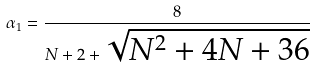Convert formula to latex. <formula><loc_0><loc_0><loc_500><loc_500>\alpha _ { 1 } = \frac { 8 } { N + 2 + \sqrt { N ^ { 2 } + 4 N + 3 6 } }</formula> 